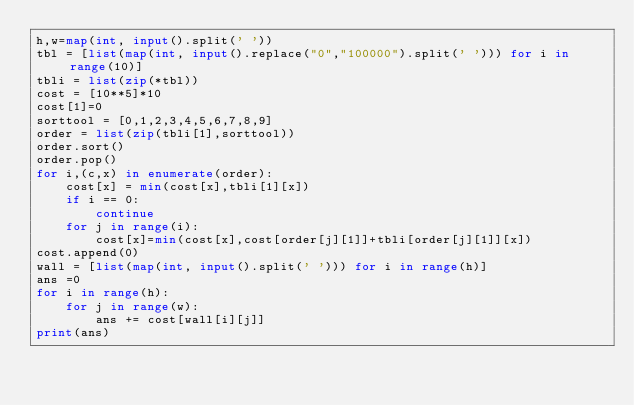Convert code to text. <code><loc_0><loc_0><loc_500><loc_500><_Python_>h,w=map(int, input().split(' '))
tbl = [list(map(int, input().replace("0","100000").split(' '))) for i in range(10)]
tbli = list(zip(*tbl))
cost = [10**5]*10
cost[1]=0
sorttool = [0,1,2,3,4,5,6,7,8,9]
order = list(zip(tbli[1],sorttool))
order.sort()
order.pop()
for i,(c,x) in enumerate(order):
    cost[x] = min(cost[x],tbli[1][x])
    if i == 0:
        continue
    for j in range(i):
        cost[x]=min(cost[x],cost[order[j][1]]+tbli[order[j][1]][x])
cost.append(0)
wall = [list(map(int, input().split(' '))) for i in range(h)]
ans =0
for i in range(h):
    for j in range(w):
        ans += cost[wall[i][j]]
print(ans)</code> 